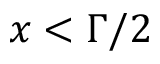<formula> <loc_0><loc_0><loc_500><loc_500>x < \Gamma / 2</formula> 